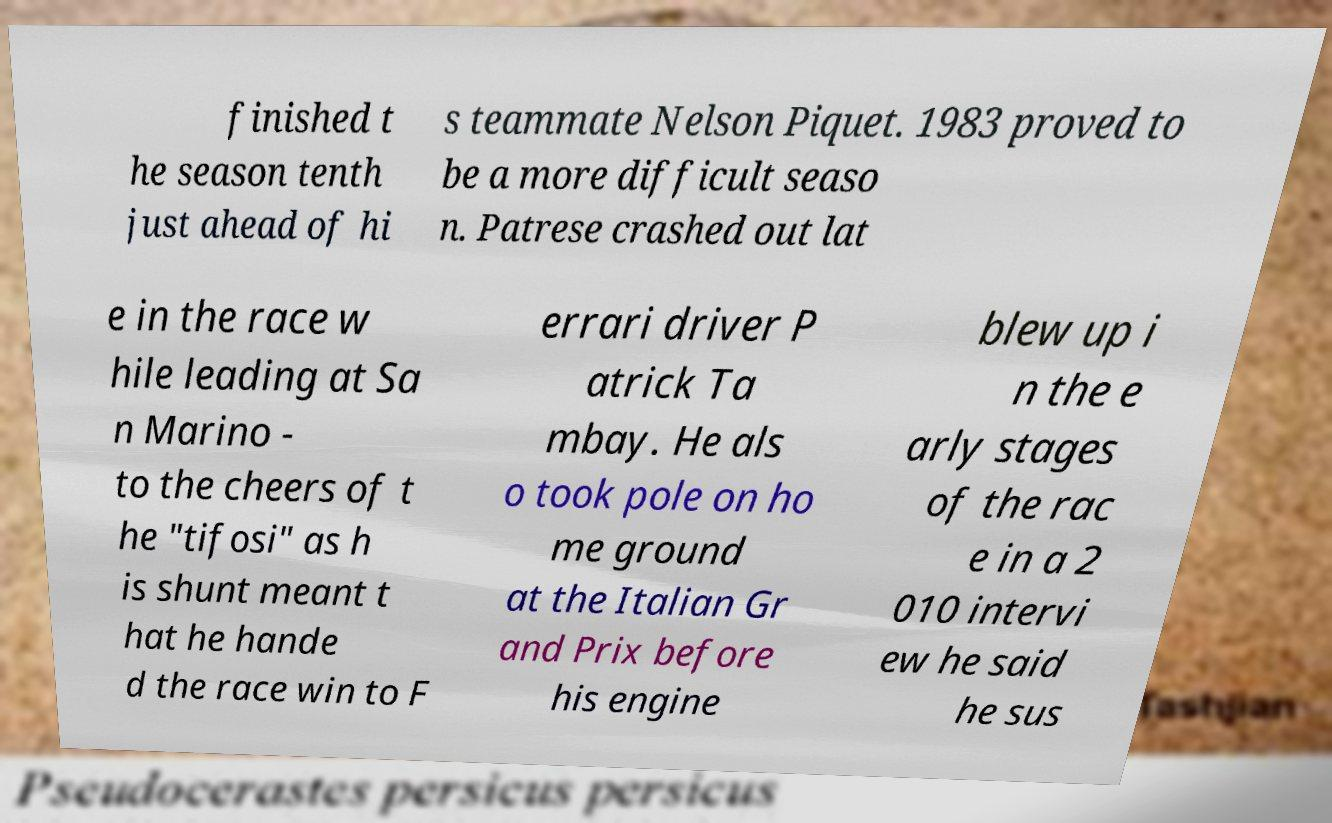Please read and relay the text visible in this image. What does it say? finished t he season tenth just ahead of hi s teammate Nelson Piquet. 1983 proved to be a more difficult seaso n. Patrese crashed out lat e in the race w hile leading at Sa n Marino - to the cheers of t he "tifosi" as h is shunt meant t hat he hande d the race win to F errari driver P atrick Ta mbay. He als o took pole on ho me ground at the Italian Gr and Prix before his engine blew up i n the e arly stages of the rac e in a 2 010 intervi ew he said he sus 